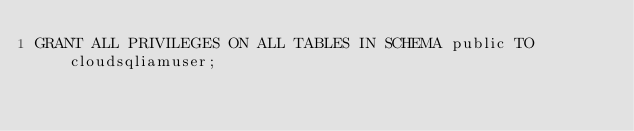Convert code to text. <code><loc_0><loc_0><loc_500><loc_500><_SQL_>GRANT ALL PRIVILEGES ON ALL TABLES IN SCHEMA public TO cloudsqliamuser;</code> 